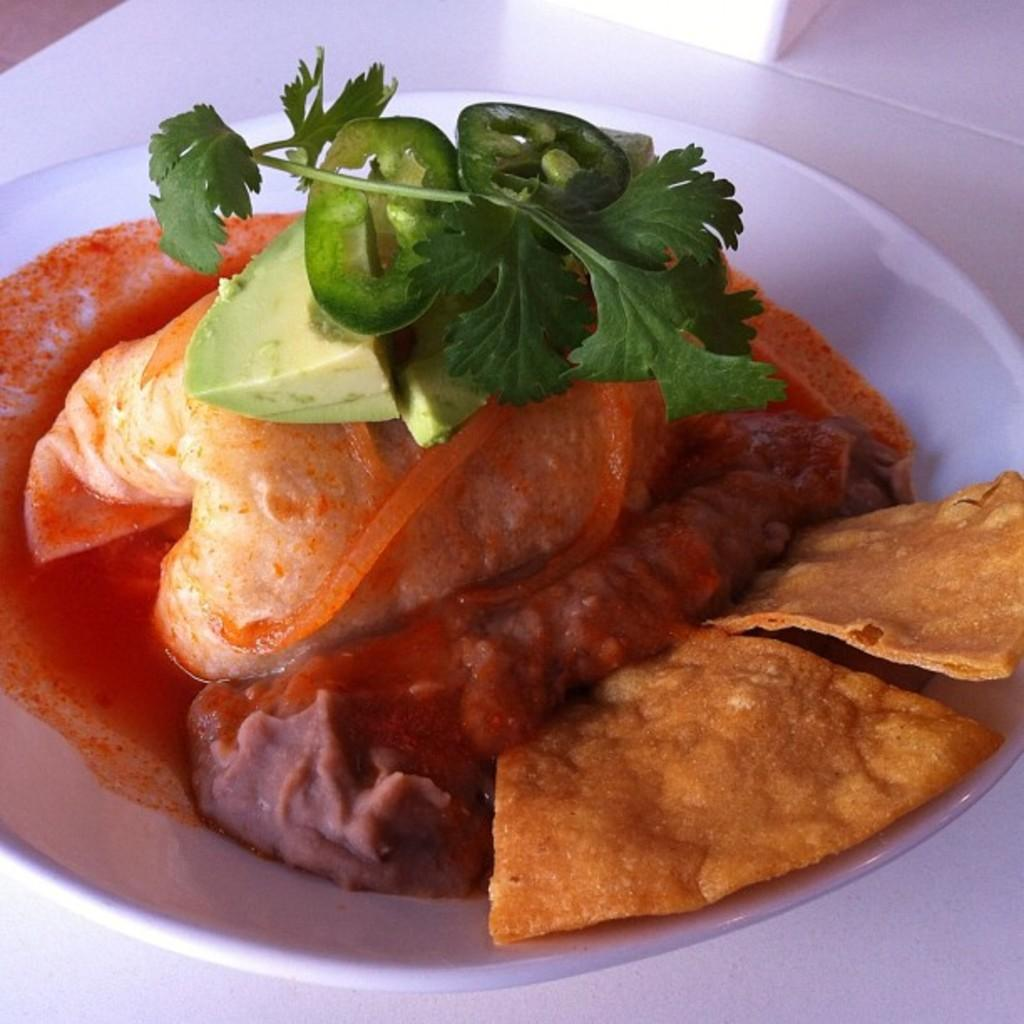What is on the plate that is visible in the image? There is a plate with food in the image. What color is the plate? The plate is white. What colors can be seen in the food on the plate? The food has green, red, and brown colors. What is the color of the surface the plate is on? The plate is on a white surface. Can you see any celery in the ice that is dropping from the ceiling in the image? There is no ice or celery present in the image, nor is there any indication of something dropping from the ceiling. 